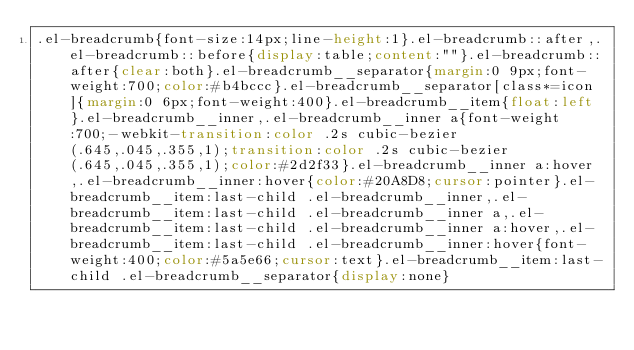Convert code to text. <code><loc_0><loc_0><loc_500><loc_500><_CSS_>.el-breadcrumb{font-size:14px;line-height:1}.el-breadcrumb::after,.el-breadcrumb::before{display:table;content:""}.el-breadcrumb::after{clear:both}.el-breadcrumb__separator{margin:0 9px;font-weight:700;color:#b4bccc}.el-breadcrumb__separator[class*=icon]{margin:0 6px;font-weight:400}.el-breadcrumb__item{float:left}.el-breadcrumb__inner,.el-breadcrumb__inner a{font-weight:700;-webkit-transition:color .2s cubic-bezier(.645,.045,.355,1);transition:color .2s cubic-bezier(.645,.045,.355,1);color:#2d2f33}.el-breadcrumb__inner a:hover,.el-breadcrumb__inner:hover{color:#20A8D8;cursor:pointer}.el-breadcrumb__item:last-child .el-breadcrumb__inner,.el-breadcrumb__item:last-child .el-breadcrumb__inner a,.el-breadcrumb__item:last-child .el-breadcrumb__inner a:hover,.el-breadcrumb__item:last-child .el-breadcrumb__inner:hover{font-weight:400;color:#5a5e66;cursor:text}.el-breadcrumb__item:last-child .el-breadcrumb__separator{display:none}</code> 